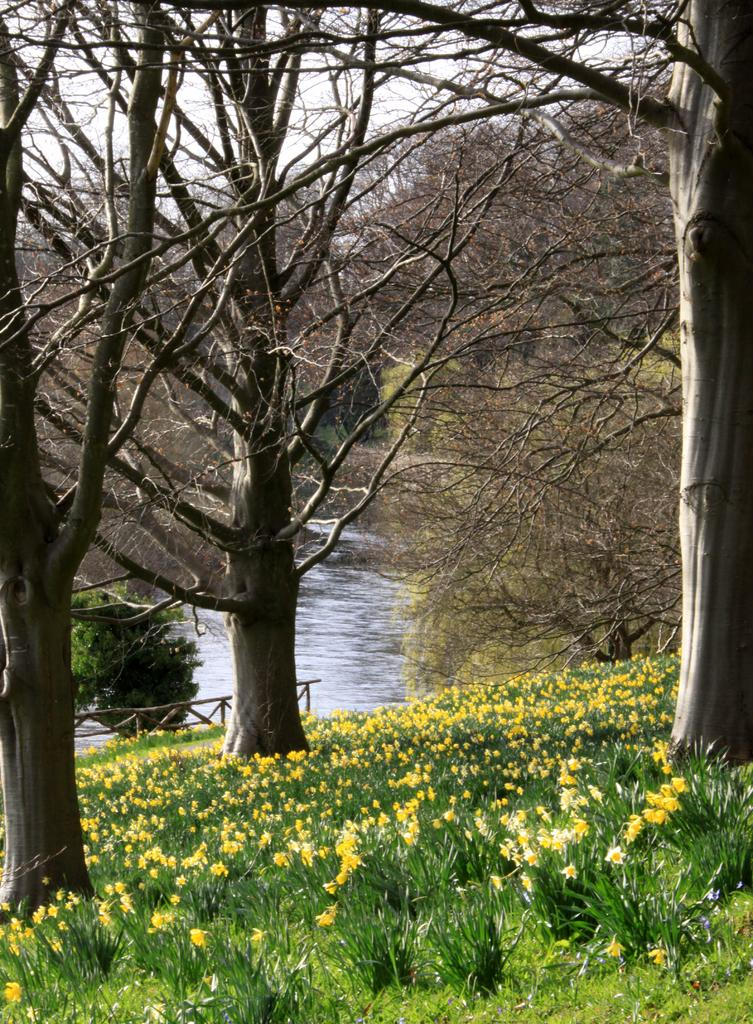What type of water body is present in the image? There is a canal in the image. What types of vegetation can be seen in the image? There are plants with flowers, dried trees, trees, bushes, and plants visible in the image. What is on the ground in the image? There is grass on the ground in the image. What is visible at the top of the image? The sky is visible at the top of the image. What word is written on the dried tree in the image? There are no words written on the dried tree in the image. How many screws can be seen holding the plants together in the image? There are no screws present in the image; plants are held together by their roots and stems. 